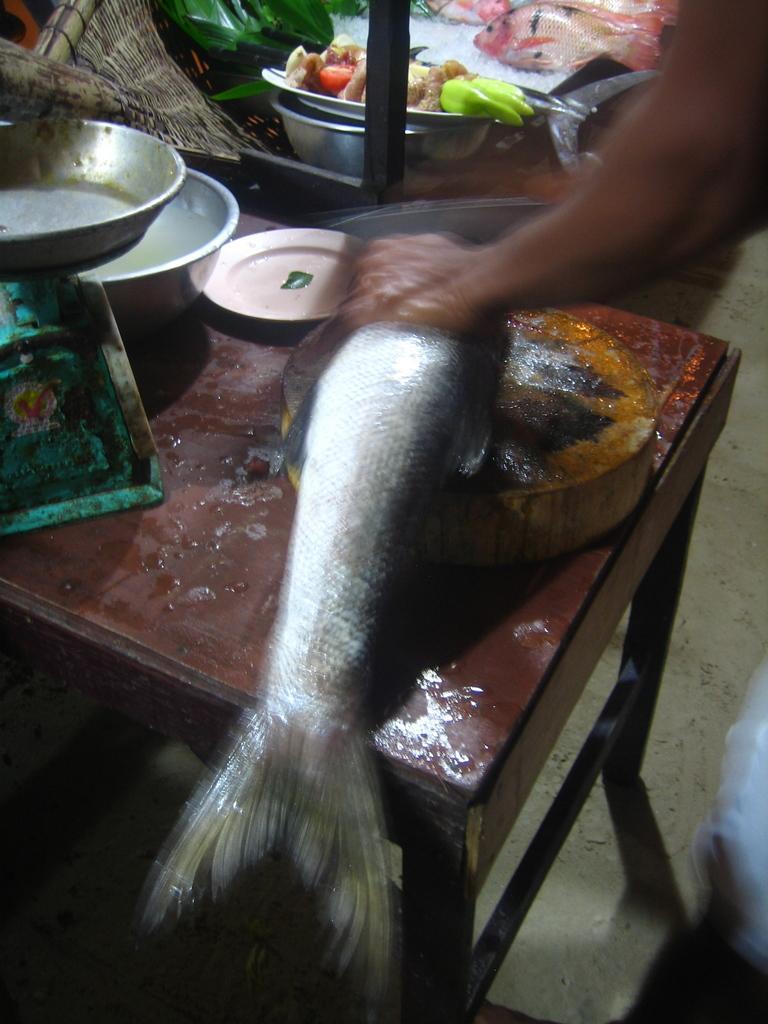Could you give a brief overview of what you see in this image? In this image we can see fish, utensils, person's hand, table and other objects. At the top of the image there is another fish, food items, utensils and other objects. In the background of the image there is the ground. 